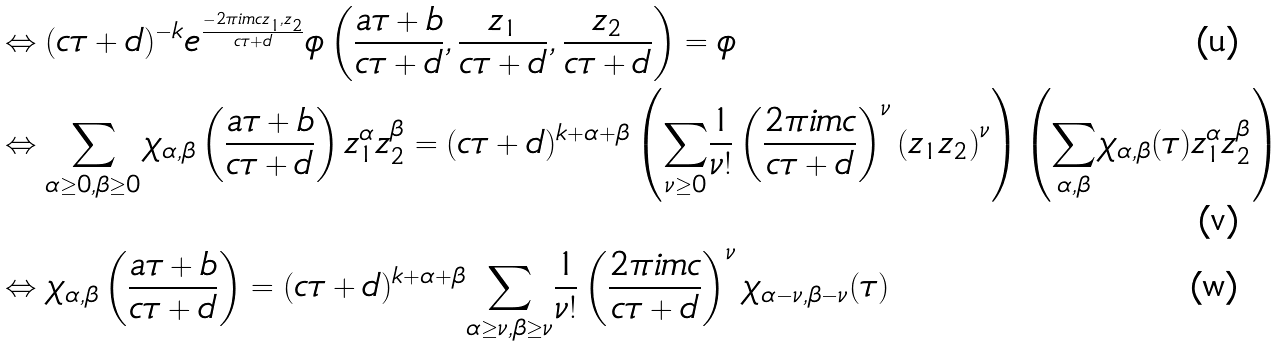Convert formula to latex. <formula><loc_0><loc_0><loc_500><loc_500>& \Leftrightarrow ( c \tau + d ) ^ { - k } e ^ { \frac { - 2 \pi i m c z _ { 1 } , z _ { 2 } } { c \tau + d } } \phi \left ( \frac { a \tau + b } { c \tau + d } , \frac { z _ { 1 } } { c \tau + d } , \frac { z _ { 2 } } { c \tau + d } \right ) = \phi \\ & \Leftrightarrow \underset { \alpha \geq 0 , \beta \geq 0 } \sum \chi _ { \alpha , \beta } \left ( \frac { a \tau + b } { c \tau + d } \right ) z _ { 1 } ^ { \alpha } z _ { 2 } ^ { \beta } = ( c \tau + d ) ^ { k + \alpha + \beta } \left ( \underset { \nu \geq 0 } \sum \frac { 1 } { \nu ! } \left ( \frac { 2 \pi i m c } { c \tau + d } \right ) ^ { \nu } \left ( z _ { 1 } z _ { 2 } \right ) ^ { \nu } \right ) \left ( \underset { \alpha , \beta } \sum \chi _ { \alpha , \beta } ( \tau ) z _ { 1 } ^ { \alpha } z _ { 2 } ^ { \beta } \right ) \\ & \Leftrightarrow \chi _ { \alpha , \beta } \left ( \frac { a \tau + b } { c \tau + d } \right ) = ( c \tau + d ) ^ { k + \alpha + \beta } \underset { \alpha \geq \nu , \beta \geq \nu } \sum \frac { 1 } { \nu ! } \left ( \frac { 2 \pi i m c } { c \tau + d } \right ) ^ { \nu } \chi _ { \alpha - \nu , \beta - \nu } ( \tau )</formula> 